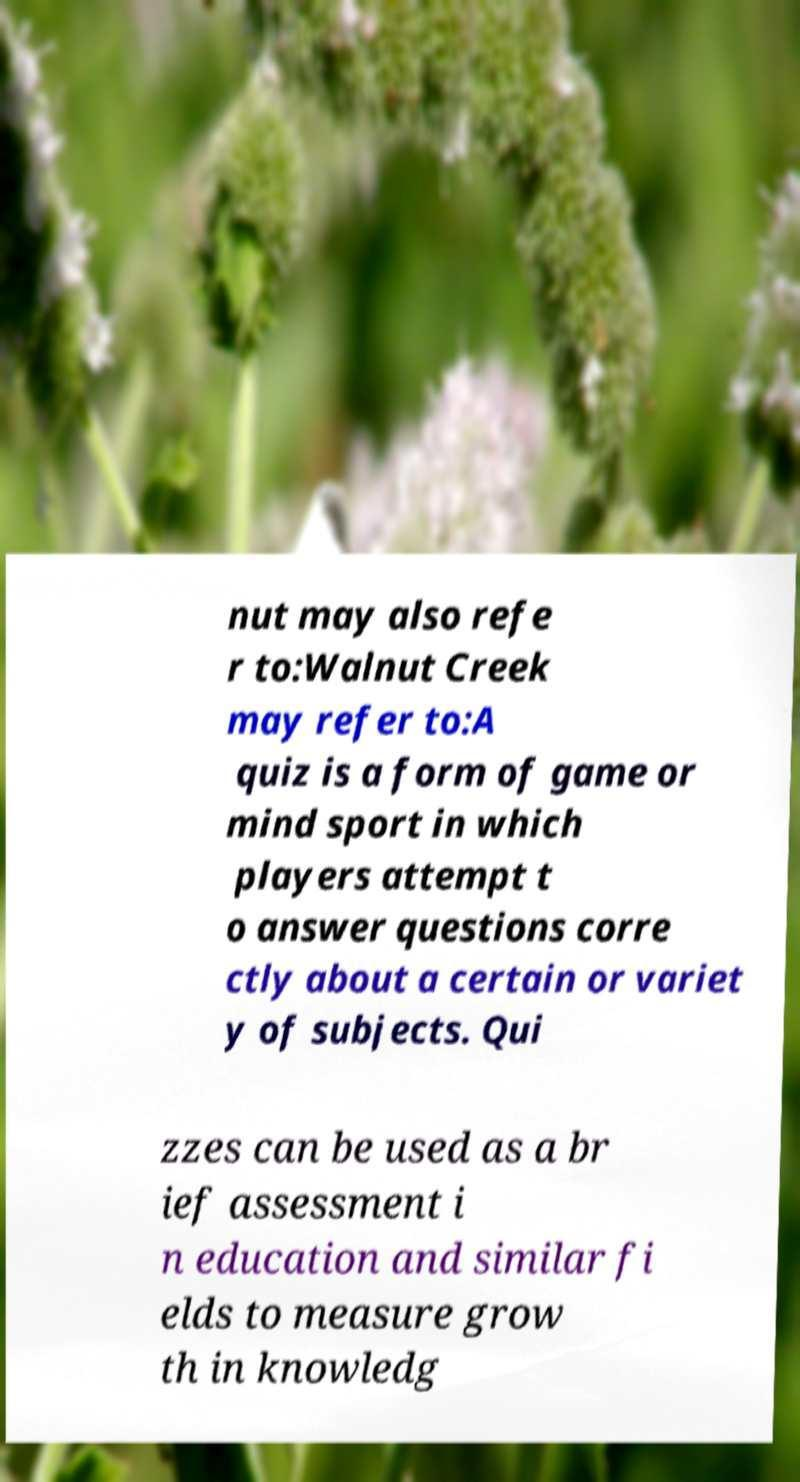For documentation purposes, I need the text within this image transcribed. Could you provide that? nut may also refe r to:Walnut Creek may refer to:A quiz is a form of game or mind sport in which players attempt t o answer questions corre ctly about a certain or variet y of subjects. Qui zzes can be used as a br ief assessment i n education and similar fi elds to measure grow th in knowledg 